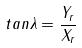Convert formula to latex. <formula><loc_0><loc_0><loc_500><loc_500>t a n \lambda = \frac { Y _ { r } } { X _ { r } }</formula> 